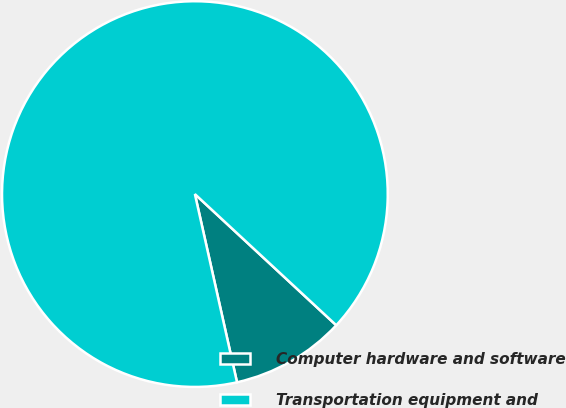Convert chart. <chart><loc_0><loc_0><loc_500><loc_500><pie_chart><fcel>Computer hardware and software<fcel>Transportation equipment and<nl><fcel>9.59%<fcel>90.41%<nl></chart> 